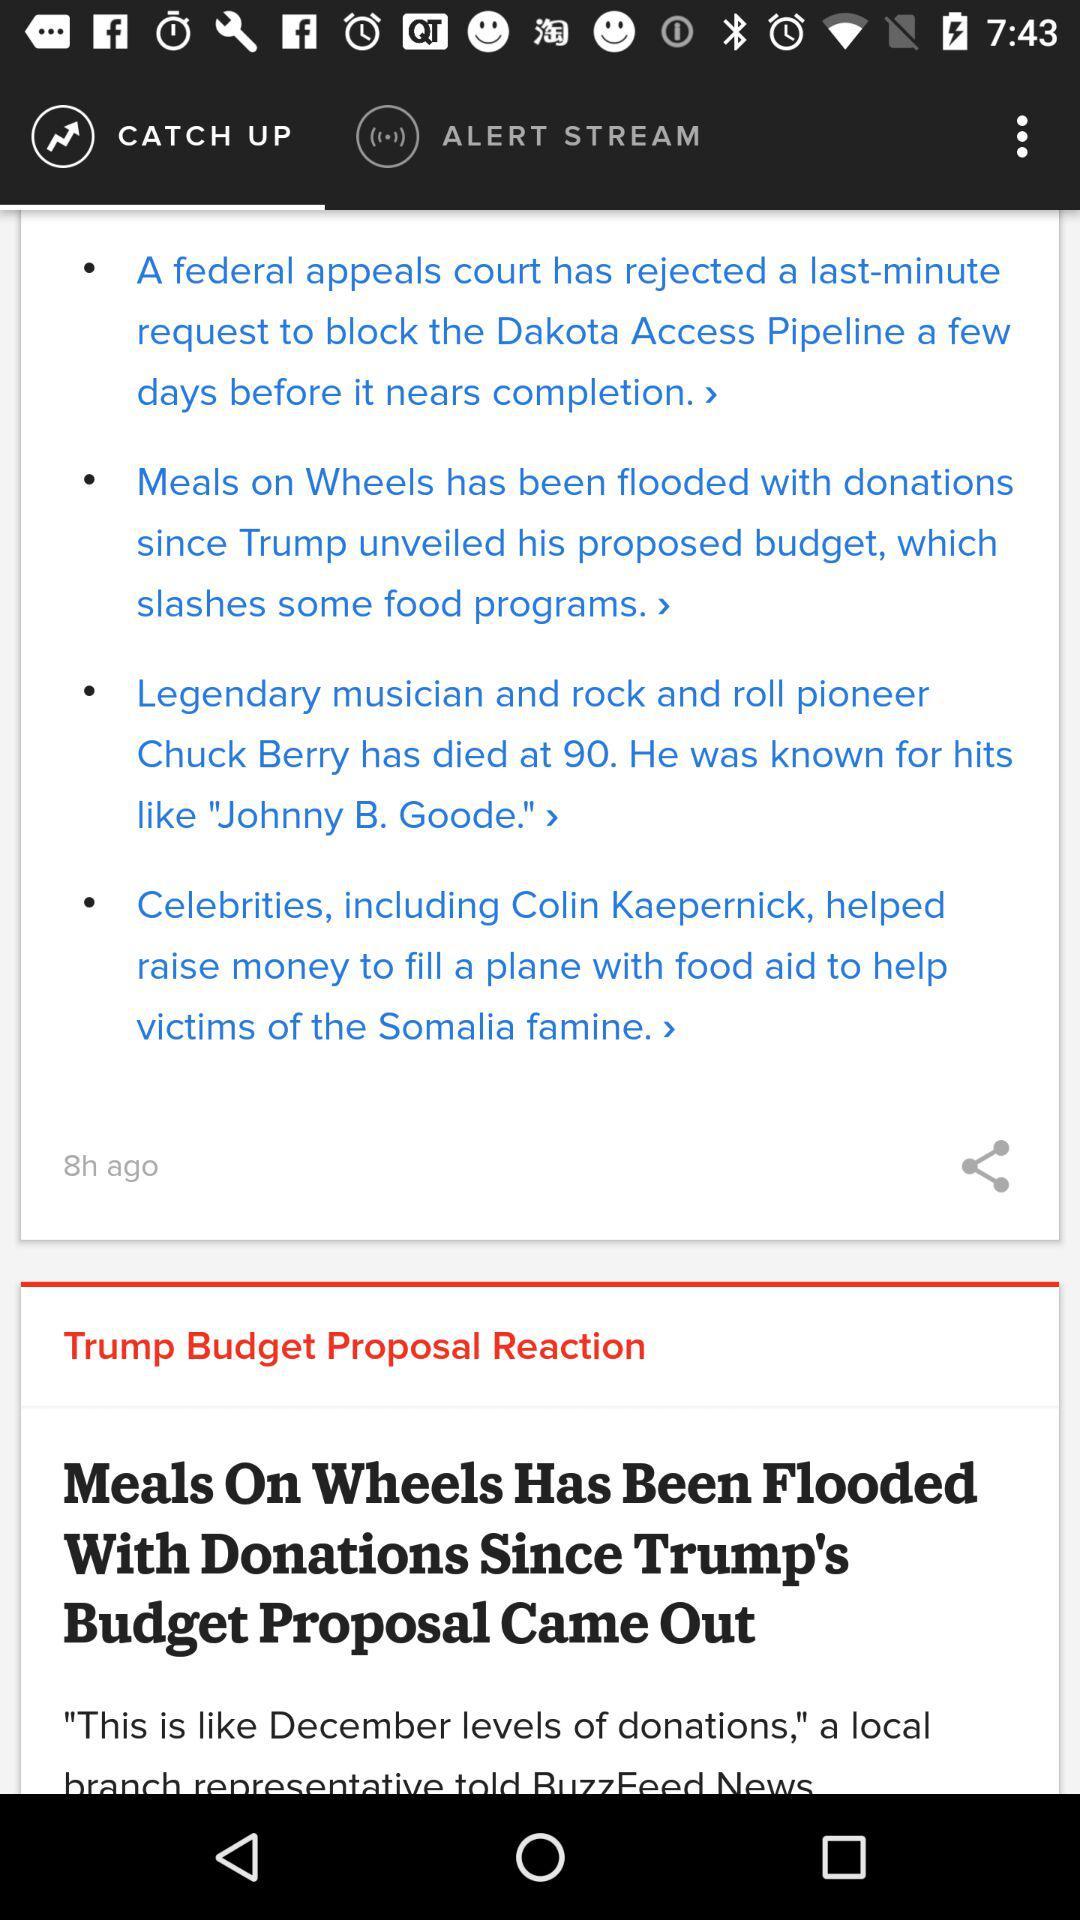Which tab is selected? The selected tab is "CATCH UP". 